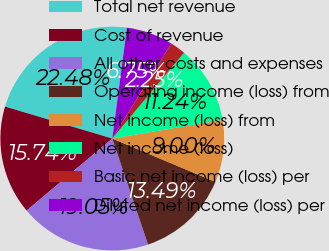<chart> <loc_0><loc_0><loc_500><loc_500><pie_chart><fcel>Total net revenue<fcel>Cost of revenue<fcel>All other costs and expenses<fcel>Operating income (loss) from<fcel>Net income (loss) from<fcel>Net income (loss)<fcel>Basic net income (loss) per<fcel>Diluted net income (loss) per<nl><fcel>22.48%<fcel>15.74%<fcel>19.05%<fcel>13.49%<fcel>9.0%<fcel>11.24%<fcel>2.25%<fcel>6.75%<nl></chart> 